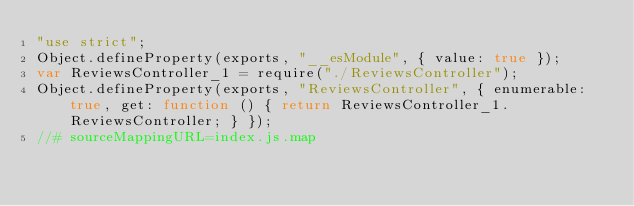<code> <loc_0><loc_0><loc_500><loc_500><_JavaScript_>"use strict";
Object.defineProperty(exports, "__esModule", { value: true });
var ReviewsController_1 = require("./ReviewsController");
Object.defineProperty(exports, "ReviewsController", { enumerable: true, get: function () { return ReviewsController_1.ReviewsController; } });
//# sourceMappingURL=index.js.map</code> 